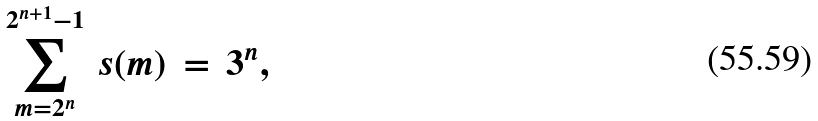<formula> <loc_0><loc_0><loc_500><loc_500>\sum _ { m = 2 ^ { n } } ^ { 2 ^ { n + 1 } - 1 } \, s ( m ) \, = \, 3 ^ { n } ,</formula> 